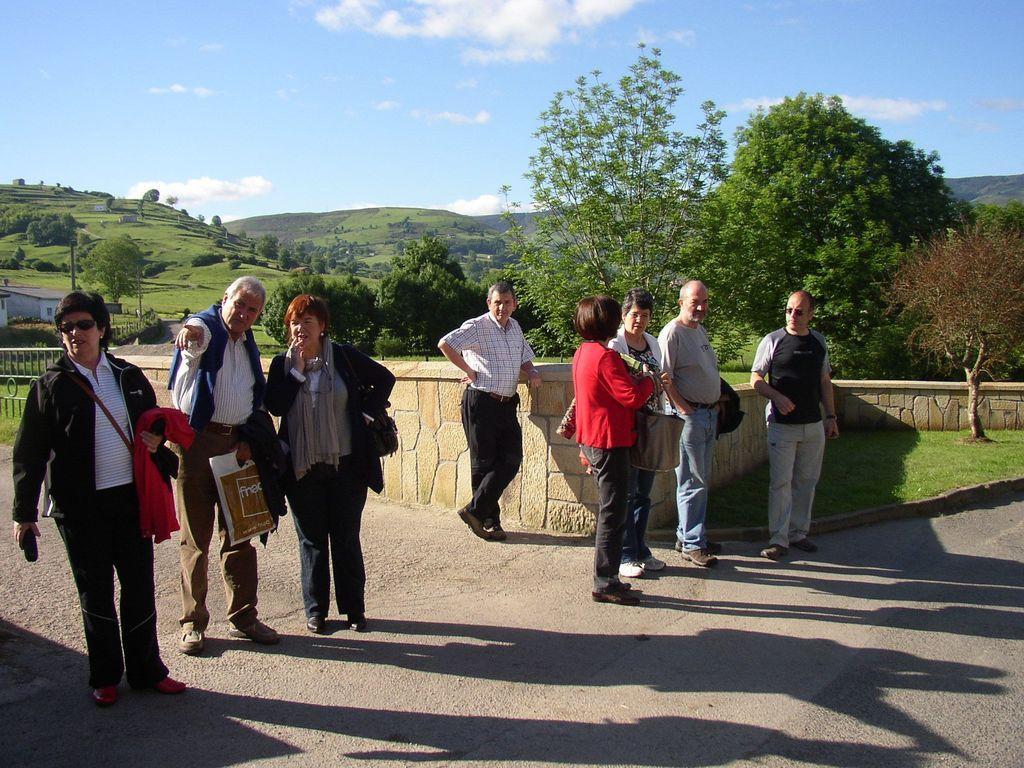In one or two sentences, can you explain what this image depicts? In this image we can see a few people, some of them are holding bags, packages, jackets, behind them there is a wall, a house, poles, trees, mountains, grass, also we can see the cloudy sky. 